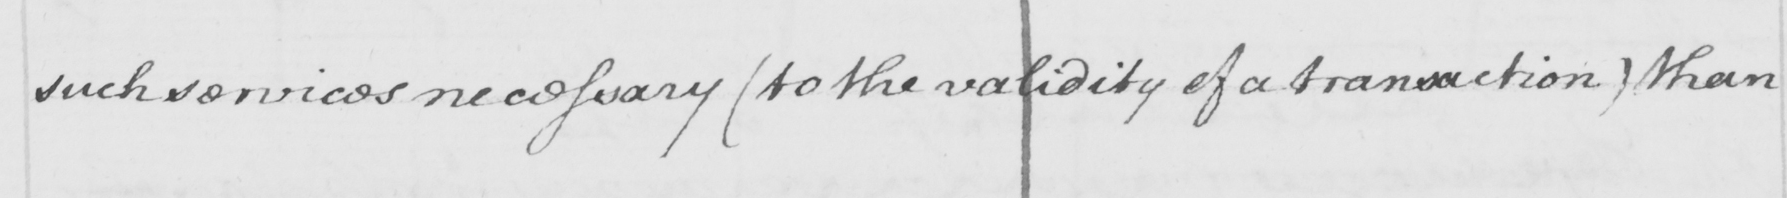Please transcribe the handwritten text in this image. such services necessary  ( to the validity of a transaction )  than 